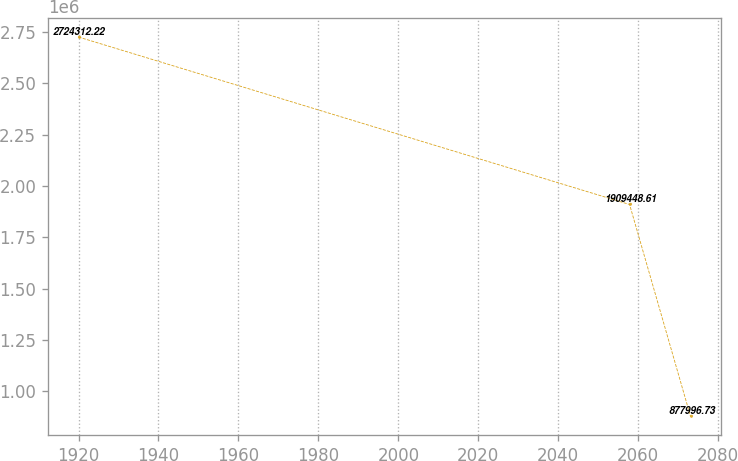Convert chart. <chart><loc_0><loc_0><loc_500><loc_500><line_chart><ecel><fcel>Unnamed: 1<nl><fcel>1919.99<fcel>2.72431e+06<nl><fcel>2057.85<fcel>1.90945e+06<nl><fcel>2073.1<fcel>877997<nl></chart> 